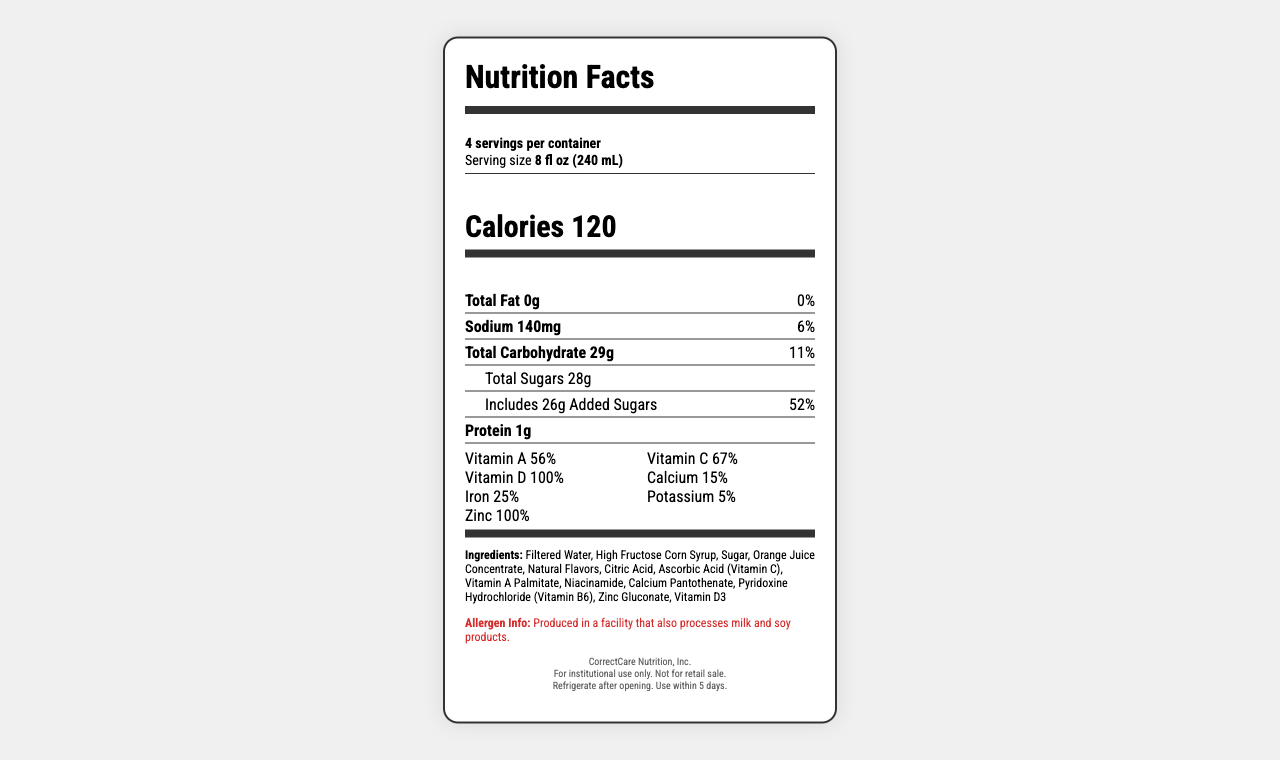what is the serving size for LockdownLift Fortified Beverage? The serving size is clearly indicated next to "Serving size" in the Nutrition Facts label.
Answer: 8 fl oz (240 mL) how many servings per container? The document states "4 servings per container" in the serving information section.
Answer: 4 how many calories are in one serving of the beverage? The calorie count for each serving is given as "Calories 120".
Answer: 120 what is the sodium content per serving? The sodium content per serving is listed as "Sodium 140mg".
Answer: 140mg what percentage of the daily value of vitamin D does one serving provide? The document shows that one serving provides "Vitamin D 100%" of the daily value.
Answer: 100% how much total carbohydrate is in one serving? The nutrient section shows "Total Carbohydrate 29g".
Answer: 29g how much added sugar is in one serving? The document states "Includes 26g Added Sugars".
Answer: 26g what is the percentage of daily value for calcium per serving? The document indicates that one serving provides "Calcium 15%" of the daily value.
Answer: 15% True or False: The beverage contains proteins. The Nutrition Facts label indicates "Protein 1g".
Answer: True which of the following vitamins has the highest percentage of daily value in one serving? A. Vitamin A B. Vitamin C C. Zinc The document shows that Zinc provides "100%" of the daily value, which is higher than Vitamin A (56%) and Vitamin C (67%).
Answer: C which of the following ingredients is not mentioned in the document? I. High Fructose Corn Syrup II. Ascorbic Acid III. Soy Milk The list of ingredients includes High Fructose Corn Syrup and Ascorbic Acid (Vitamin C) but does not mention Soy Milk.
Answer: III what is the main idea of the Nutrition Facts label for LockdownLift Fortified Beverage? The document includes sections on serving size, calorie count, nutrient content, vitamins and minerals, ingredients, allergen information, manufacturer details, and storage instructions.
Answer: The main idea is to provide detailed nutritional information, serving sizes, ingredient list, and allergen warnings for the LockdownLift Fortified Beverage. how much vitamin A is in one serving of the beverage? The Nutrition Facts label indicates that each serving contains "Vitamin A 500mcg".
Answer: 500mcg can we determine the production cost of this beverage from this document? The Nutrition Facts label provides nutritional information, ingredients, and other details but does not include any information about production costs.
Answer: Not enough information 